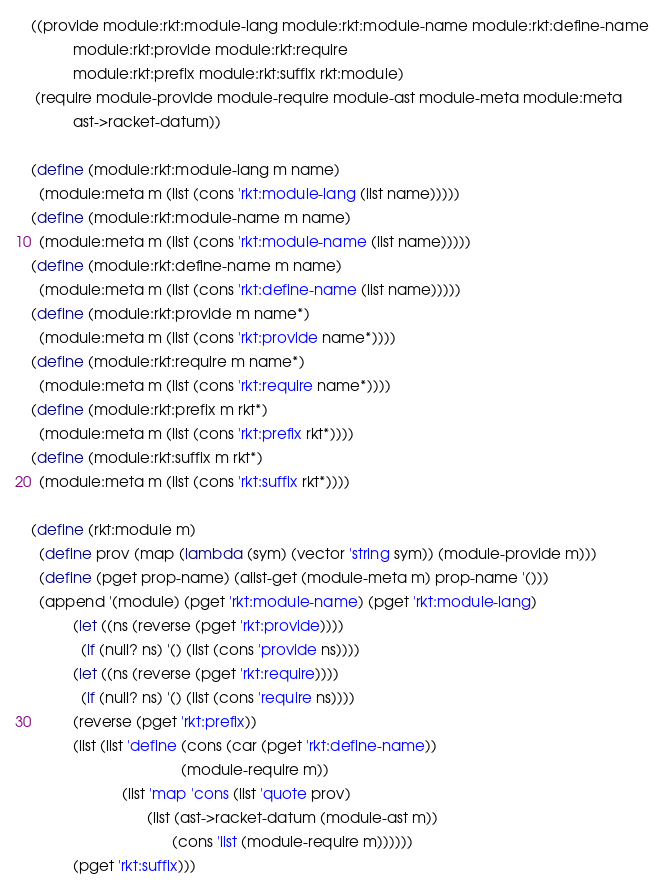Convert code to text. <code><loc_0><loc_0><loc_500><loc_500><_Scheme_>((provide module:rkt:module-lang module:rkt:module-name module:rkt:define-name
          module:rkt:provide module:rkt:require
          module:rkt:prefix module:rkt:suffix rkt:module)
 (require module-provide module-require module-ast module-meta module:meta
          ast->racket-datum))

(define (module:rkt:module-lang m name)
  (module:meta m (list (cons 'rkt:module-lang (list name)))))
(define (module:rkt:module-name m name)
  (module:meta m (list (cons 'rkt:module-name (list name)))))
(define (module:rkt:define-name m name)
  (module:meta m (list (cons 'rkt:define-name (list name)))))
(define (module:rkt:provide m name*)
  (module:meta m (list (cons 'rkt:provide name*))))
(define (module:rkt:require m name*)
  (module:meta m (list (cons 'rkt:require name*))))
(define (module:rkt:prefix m rkt*)
  (module:meta m (list (cons 'rkt:prefix rkt*))))
(define (module:rkt:suffix m rkt*)
  (module:meta m (list (cons 'rkt:suffix rkt*))))

(define (rkt:module m)
  (define prov (map (lambda (sym) (vector 'string sym)) (module-provide m)))
  (define (pget prop-name) (alist-get (module-meta m) prop-name '()))
  (append '(module) (pget 'rkt:module-name) (pget 'rkt:module-lang)
          (let ((ns (reverse (pget 'rkt:provide))))
            (if (null? ns) '() (list (cons 'provide ns))))
          (let ((ns (reverse (pget 'rkt:require))))
            (if (null? ns) '() (list (cons 'require ns))))
          (reverse (pget 'rkt:prefix))
          (list (list 'define (cons (car (pget 'rkt:define-name))
                                    (module-require m))
                      (list 'map 'cons (list 'quote prov)
                            (list (ast->racket-datum (module-ast m))
                                  (cons 'list (module-require m))))))
          (pget 'rkt:suffix)))
</code> 